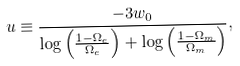Convert formula to latex. <formula><loc_0><loc_0><loc_500><loc_500>u \equiv \frac { - 3 w _ { 0 } } { \log { \left ( \frac { 1 - \Omega _ { e } } { \Omega _ { e } } \right ) } + \log { \left ( \frac { 1 - \Omega _ { m } } { \Omega _ { m } } \right ) } } ,</formula> 